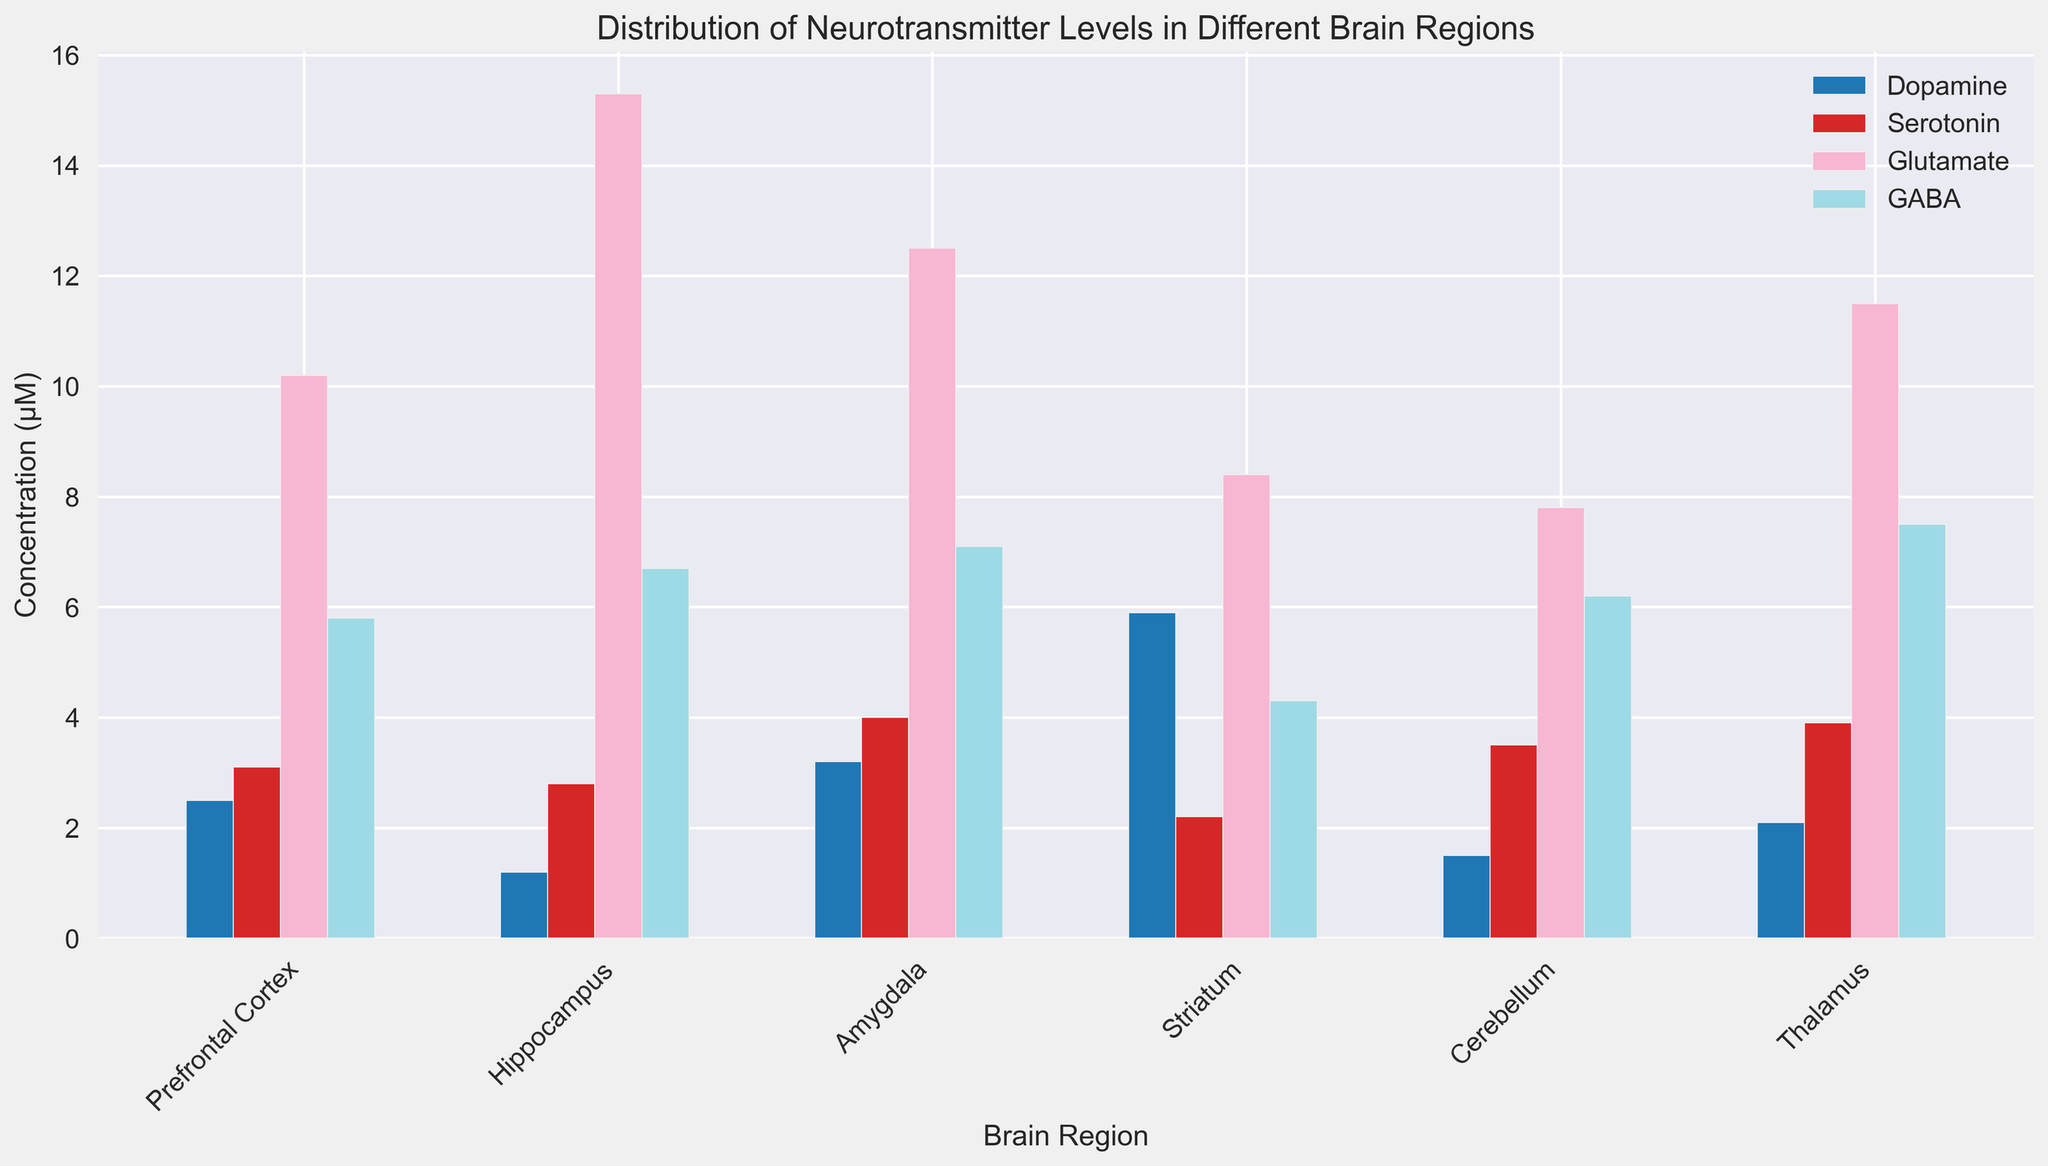What's the brain region with the highest concentration of Glutamate? Look for the tallest bar representing Glutamate. The highest Glutamate concentration is in the Hippocampus with a concentration of 15.3 µM.
Answer: Hippocampus Which brain region has the lowest concentration of Dopamine? Look for the smallest bar representing Dopamine. The lowest concentration of Dopamine is in the Hippocampus with a concentration of 1.2 µM.
Answer: Hippocampus Among Serotonin levels across all brain regions, which two regions have the closest concentrations? Compare the heights of the bars representing Serotonin. The Prefrontal Cortex has a concentration of 3.1 µM and the Cerebellum has a concentration of 3.5 µM, which are the closest.
Answer: Prefrontal Cortex and Cerebellum What is the average concentration of GABA across all brain regions? Add the concentrations of GABA in all brain regions and divide by the number of regions: (5.8 + 6.7 + 7.1 + 4.3 + 6.2 + 7.5) / 6 = 37.6 / 6 = 6.27 µM
Answer: 6.27 µM Which neurotransmitter has the most consistent concentration across the different brain regions? Look for the neurotransmitter bars with the least variation in height. Serotonin bars (3.1, 2.8, 4.0, 2.2, 3.5, 3.9) vary less compared to others.
Answer: Serotonin What is the difference in Dopamine concentration between the Striatum and the Cerebellum? Subtract the Dopamine concentration in the Cerebellum from that in the Striatum: 5.9 - 1.5 = 4.4 µM
Answer: 4.4 µM Which neurotransmitter’s concentration is highest in the Amygdala compared to other brain regions? Compare the height of each neurotransmitter bar in the Amygdala to its corresponding bars in other regions. GABA has its highest concentration in the Amygdala (7.1 µM).
Answer: GABA Is the concentration of Glutamate higher in the Thalamus or the Prefrontal Cortex? Compare the height of the Glutamate bars in the Thalamus and the Prefrontal Cortex. The Thalamus has a higher concentration (11.5 µM) compared to the Prefrontal Cortex (10.2 µM).
Answer: Thalamus What's the total concentration of Serotonin in all brain regions? Sum up the Serotonin concentrations across all brain regions: 3.1 + 2.8 + 4.0 + 2.2 + 3.5 + 3.9 = 19.5 µM
Answer: 19.5 µM How does the concentration of GABA in the Thalamus compare to that in the Hippocampus? Compare the height of the GABA bar in the Thalamus to that in the Hippocampus. The Thalamus has a higher concentration (7.5 µM) compared to the Hippocampus (6.7 µM).
Answer: Thalamus 